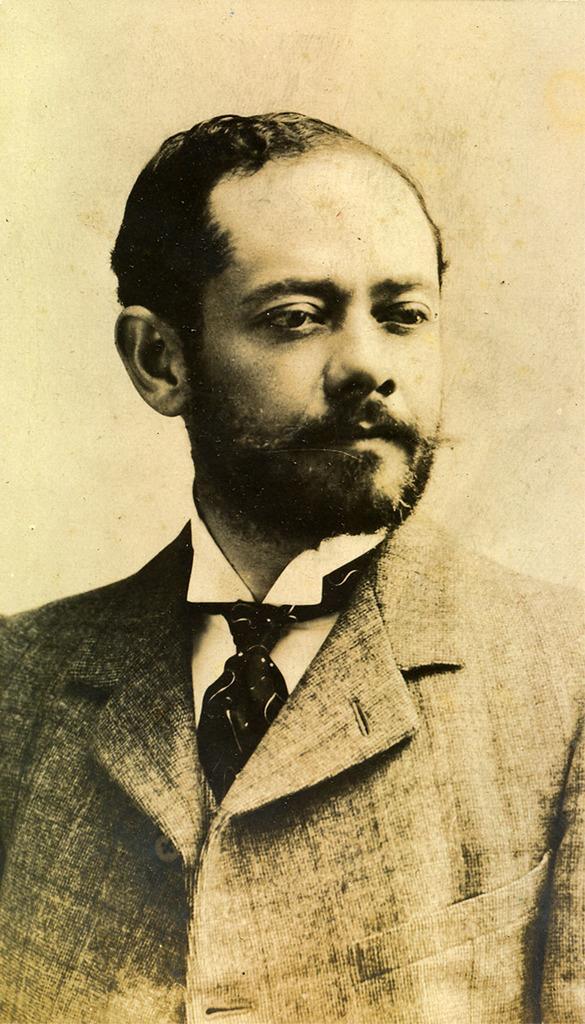Can you describe this image briefly? In this image we can see a man and in the background there is a wall. 